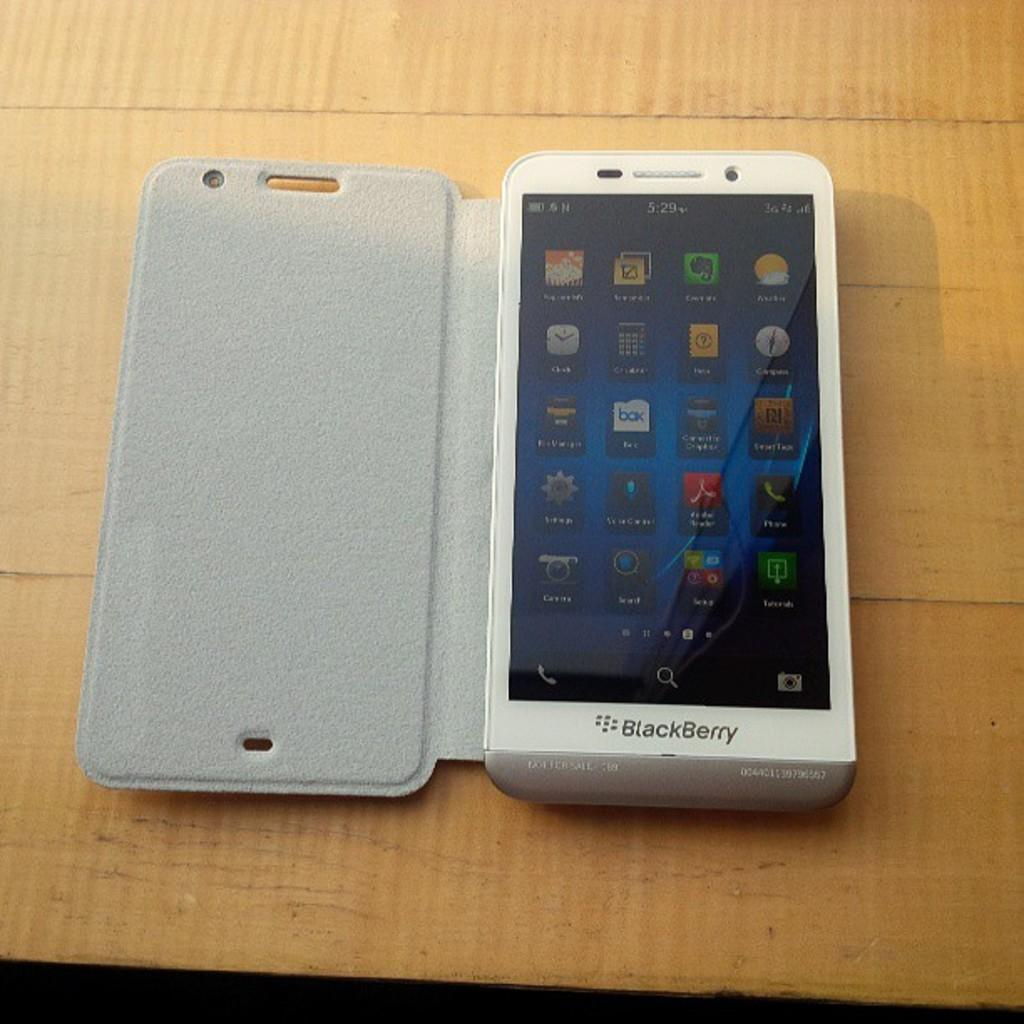<image>
Give a short and clear explanation of the subsequent image. An unusually thick Blackberry device is displayed open upon a wooden table. 